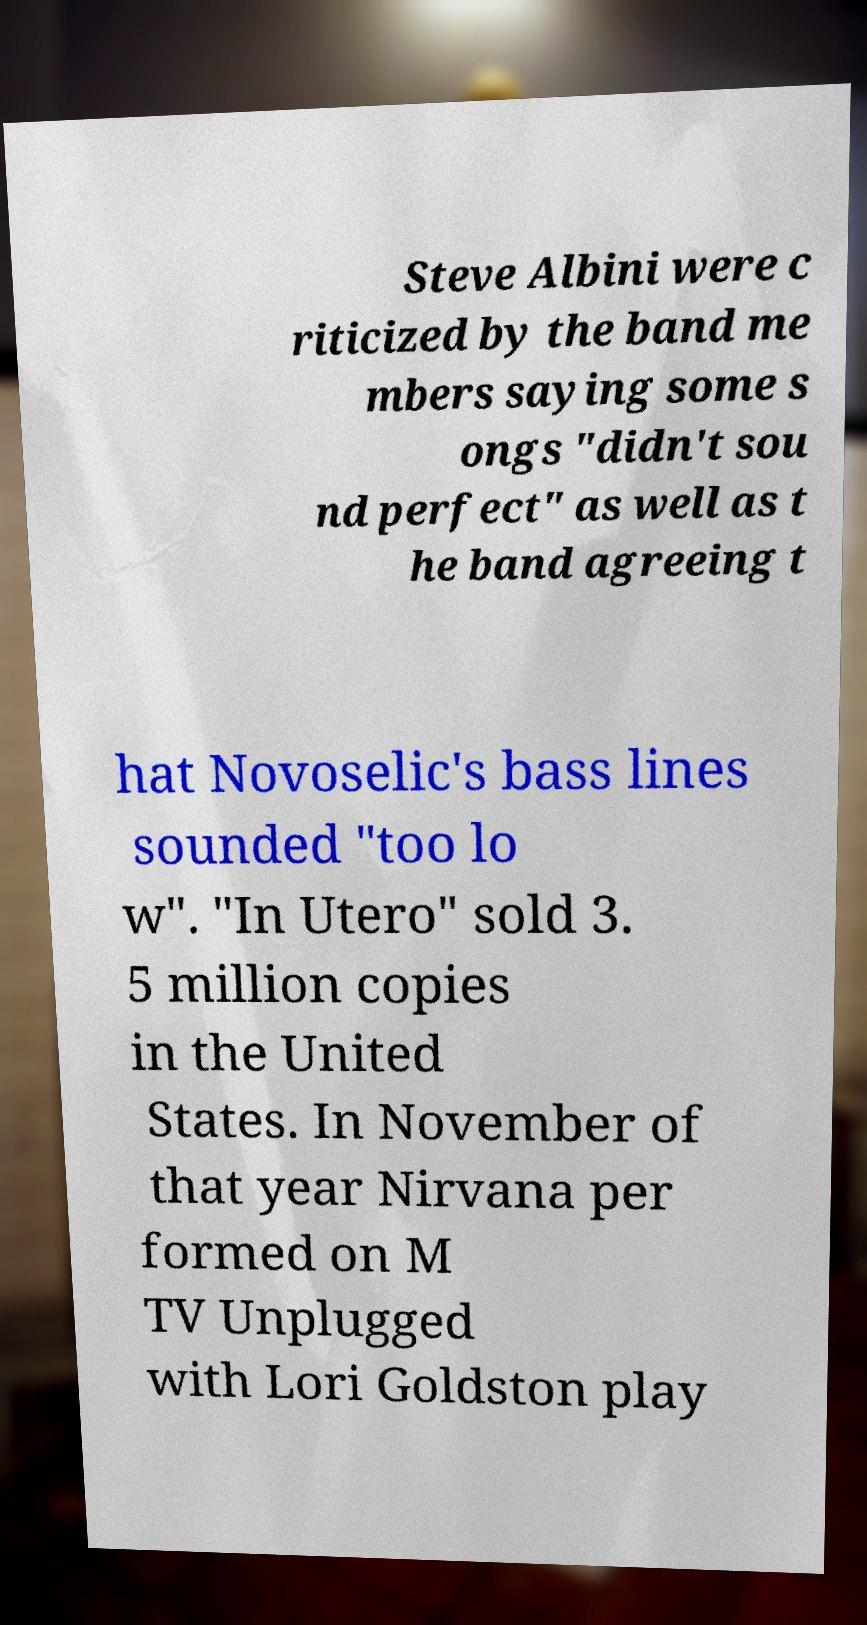Can you accurately transcribe the text from the provided image for me? Steve Albini were c riticized by the band me mbers saying some s ongs "didn't sou nd perfect" as well as t he band agreeing t hat Novoselic's bass lines sounded "too lo w". "In Utero" sold 3. 5 million copies in the United States. In November of that year Nirvana per formed on M TV Unplugged with Lori Goldston play 